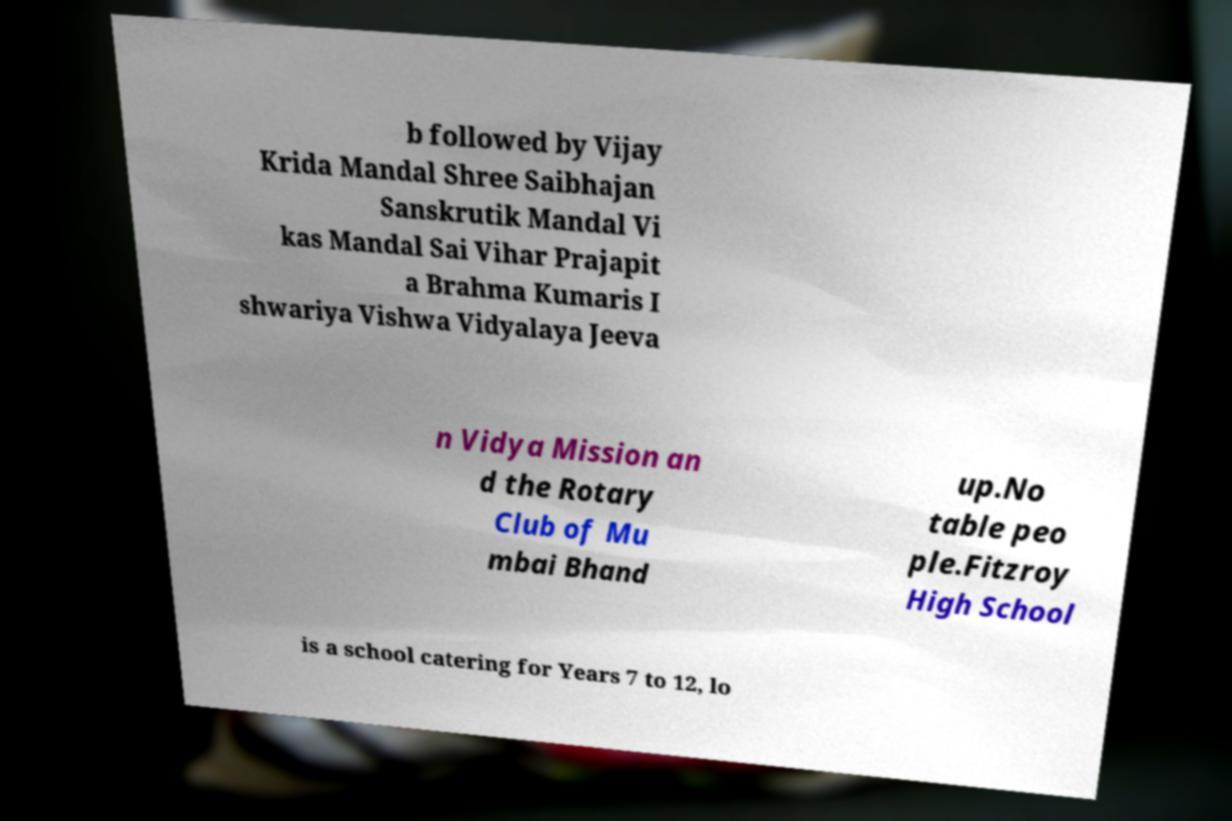Can you accurately transcribe the text from the provided image for me? b followed by Vijay Krida Mandal Shree Saibhajan Sanskrutik Mandal Vi kas Mandal Sai Vihar Prajapit a Brahma Kumaris I shwariya Vishwa Vidyalaya Jeeva n Vidya Mission an d the Rotary Club of Mu mbai Bhand up.No table peo ple.Fitzroy High School is a school catering for Years 7 to 12, lo 